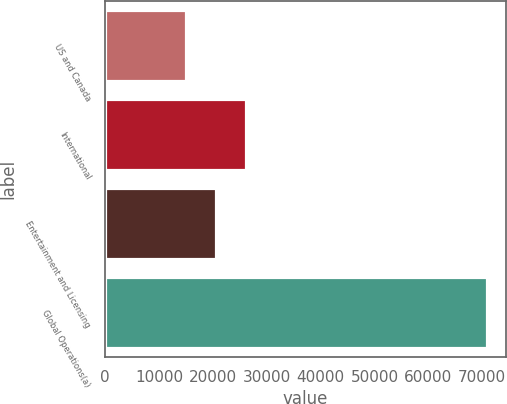Convert chart to OTSL. <chart><loc_0><loc_0><loc_500><loc_500><bar_chart><fcel>US and Canada<fcel>International<fcel>Entertainment and Licensing<fcel>Global Operations(a)<nl><fcel>14946<fcel>26115.6<fcel>20530.8<fcel>70794<nl></chart> 